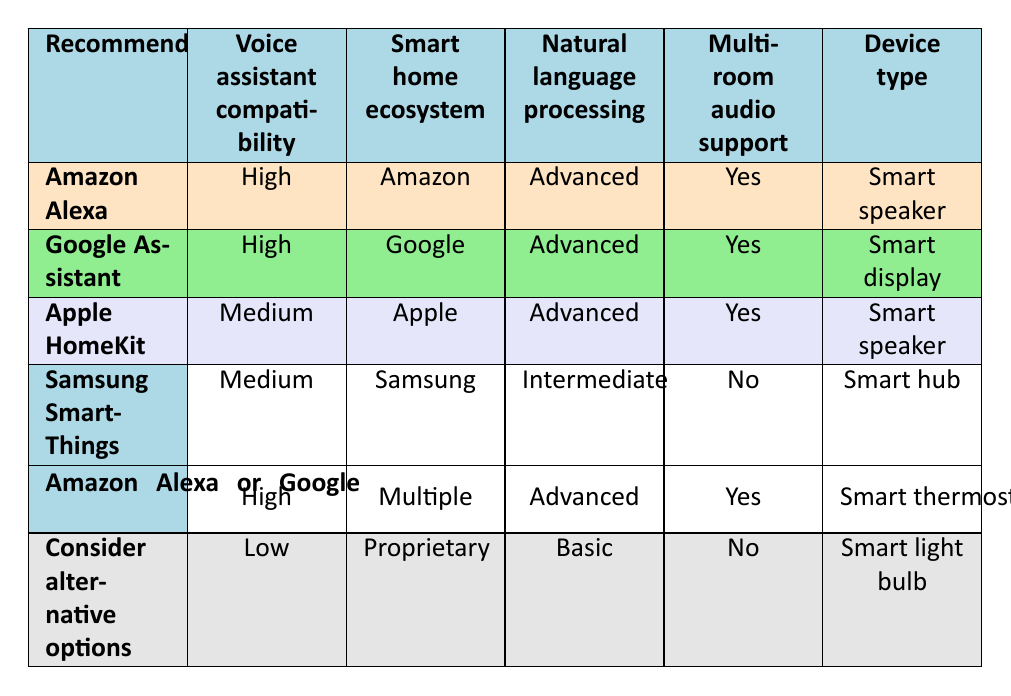What is the recommendation for a smart speaker with high voice assistant compatibility? The table shows that Amazon Alexa is recommended for a smart speaker with high voice assistant compatibility.
Answer: Amazon Alexa Which voice assistants support multi-room audio? Both Amazon Alexa and Google Assistant support multi-room audio, as indicated in their respective rows where it states "Yes" under multi-room audio support.
Answer: Amazon Alexa and Google Assistant Is Samsung SmartThings compatible with high voice assistant integration? The compatibility for Samsung SmartThings is rated as "Medium", which does not qualify it as high compatibility. Thus, the answer is no.
Answer: No What type of device is recommended if someone wants a high compatibility voice assistant with advanced natural language processing? Looking at the table, both Amazon Alexa and Google Assistant are recommended for such conditions, with the associated device types being "Smart speaker" and "Smart display" respectively.
Answer: Amazon Alexa or Google Assistant What is the natural language processing rating for Apple HomeKit? The table indicates that Apple HomeKit has an "Advanced" rating for natural language processing.
Answer: Advanced Which device type has a low recommendation, and what is its smart home ecosystem? The table specifies that the device type "Smart light bulb" has a low recommendation, and its smart home ecosystem is "Proprietary."
Answer: Smart light bulb, Proprietary How many voice assistants are recommended for a smart thermostat? The table mentions that both "Amazon Alexa" and "Google Assistant" can be recommended for a smart thermostat, amounting to two choices.
Answer: 2 What device type is associated with medium voice assistant compatibility and no multi-room audio support? The table indicates that "Smart hub" is the device type associated with medium compatibility and 'No' under multi-room audio support for Samsung SmartThings.
Answer: Smart hub How would you categorize the voice assistant compatibility for Google Assistant? The table marks Google Assistant's voice assistant compatibility as "High", which is a strong rating for compatibility across various devices.
Answer: High 